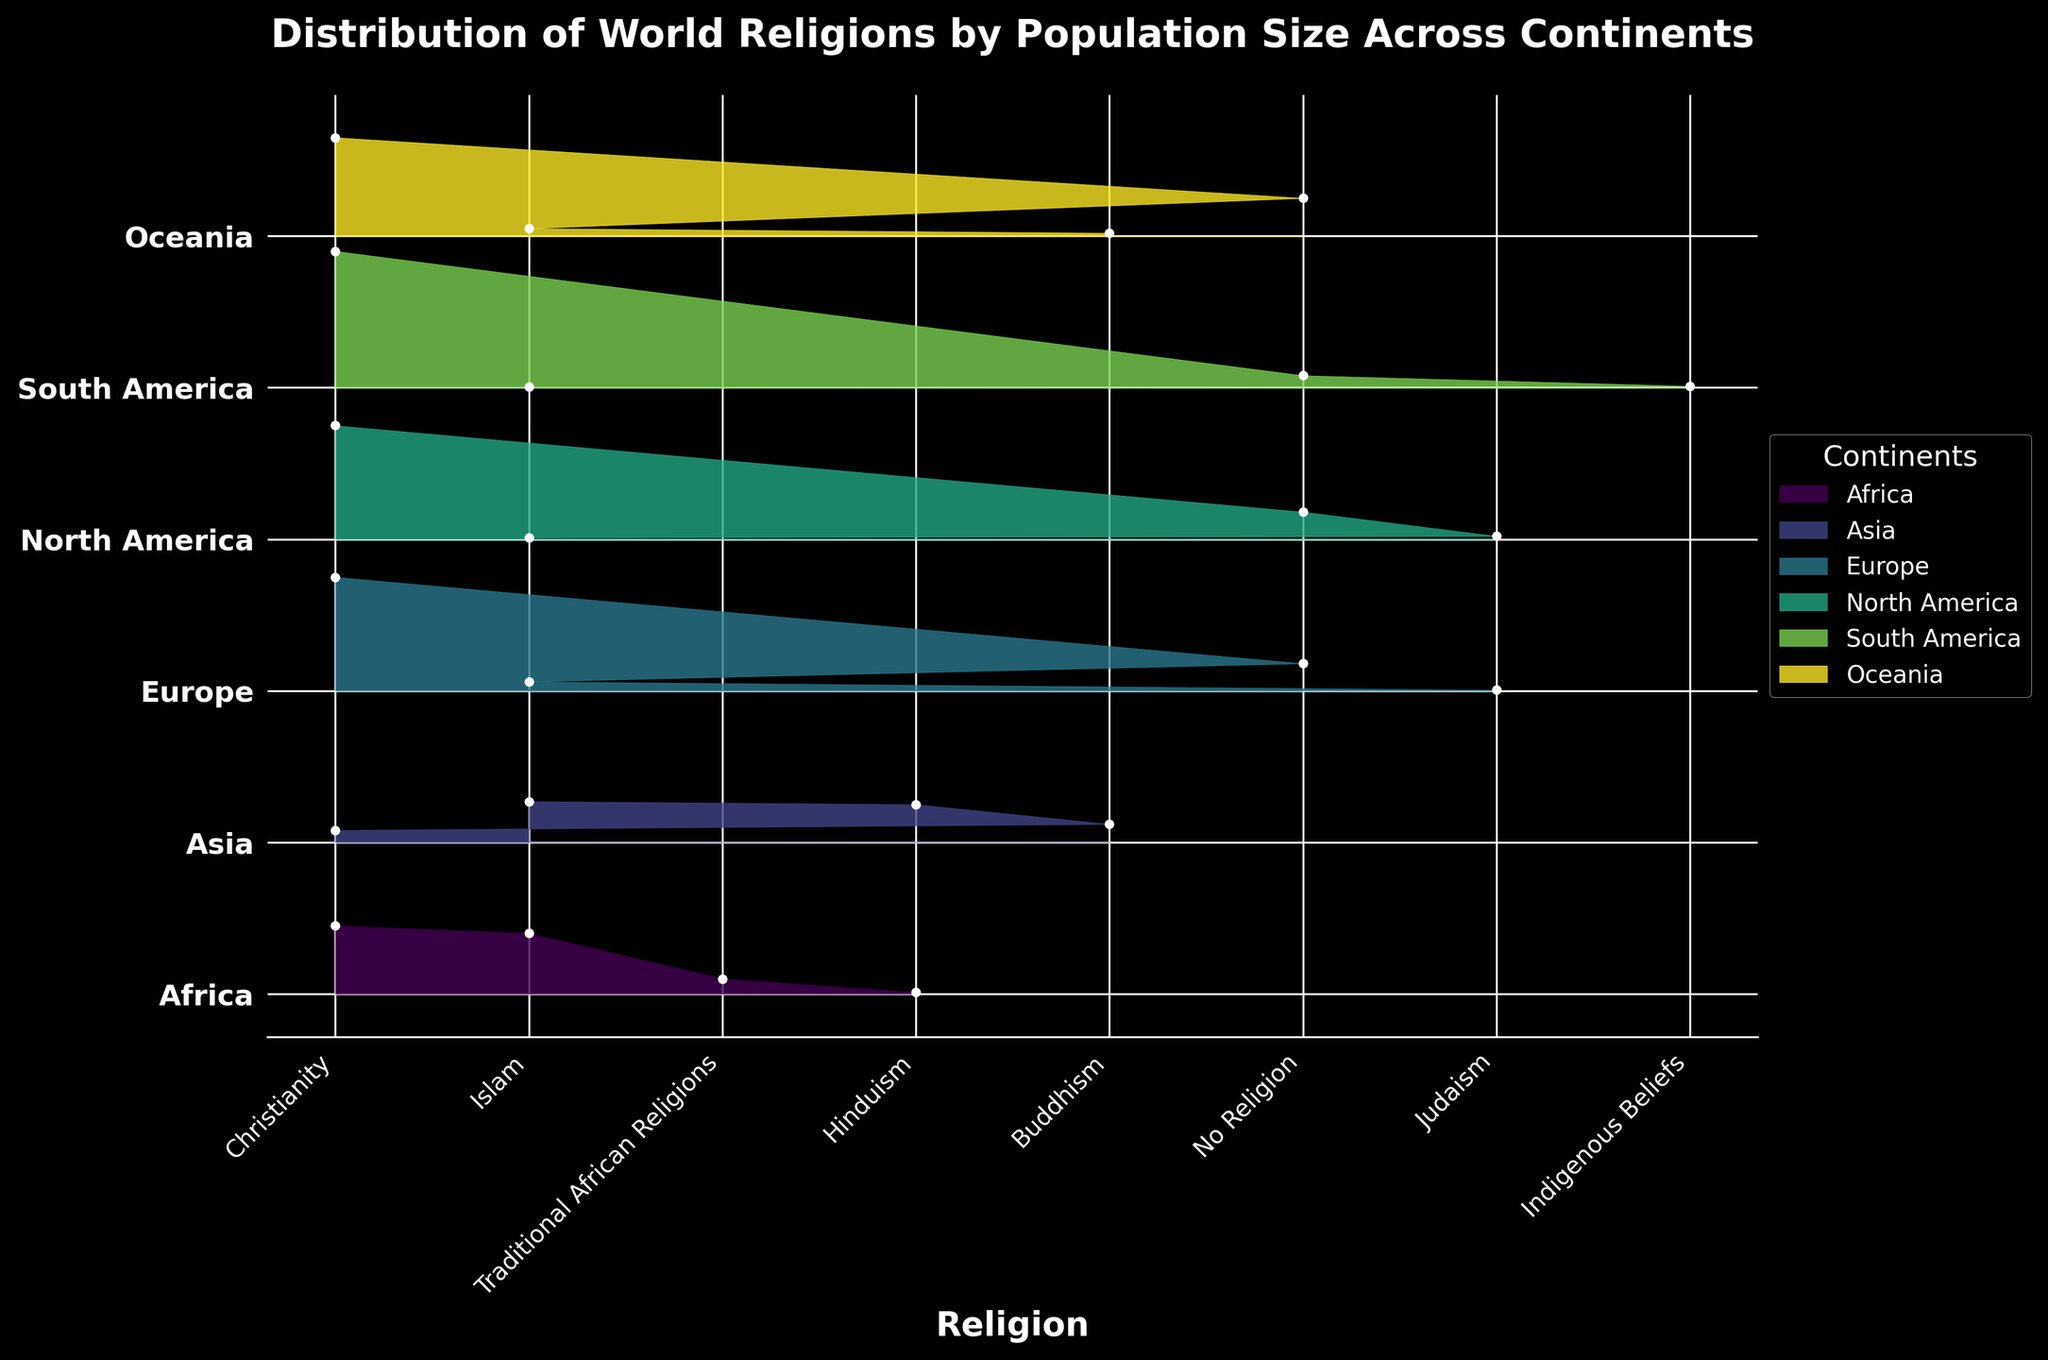What is the title of the plot? The title is located at the top of the plot and provides the overall description of what the plot is about. In this instance, it's written clearly in bold.
Answer: Distribution of World Religions by Population Size Across Continents Which continent has the highest percentage of the population practicing Christianity? To determine this, look for the tallest peak representing Christianity across all continents. Verify by comparing each peak labeled "Christianity."
Answer: South America Which continent shows the highest percentage for Islam? To find this, examine the peaks labeled 'Islam' and identify the highest one by comparing the values visually.
Answer: Asia How does the percentage of people with 'No Religion' in Europe compare with that in North America? Look at the heights of the 'No Religion' peaks for both Europe and North America and compare them directly.
Answer: Europe has a slightly higher percentage What are the three most prevalent religions in Asia by population percentage? Identify and list the top three highest peaks in the Asia section, considering the corresponding religious labels.
Answer: Islam, Hinduism, Buddhism Which continent has the smallest representation of Judaism, and what's the percentage? Look at the peaks labeled 'Judaism' and find the smallest one among the continents. Read off the corresponding value.
Answer: Europe, 0.5% Which continent has a distinct presence of Indigenous Beliefs? Identify the presence of any peaks specifically labeled 'Indigenous Beliefs' and find the associated continent.
Answer: South America What is the sum of population percentages practicing Islam across all continents? Add the percentages of the population practicing Islam for each continent step-by-step: 40 (Africa) + 27 (Asia) + 6 (Europe) + 1 (North America) + 0.5 (South America) + 5 (Oceania).
Answer: 79.5% In which continent does Buddhism have the smallest population percentage, excluding continents where it is absent? Compare the percentages of Buddhism across continents where it is present, and find the smallest one. Populations in Africa, Asia, and Oceania provide the relevant percentages.
Answer: Oceania What is the difference in the percentage of the Christian population between Oceania and North America? Subtract the percentage of Christianity in Oceania from that in North America. Calculate: 75 (North America) - 65 (Oceania).
Answer: 10% 